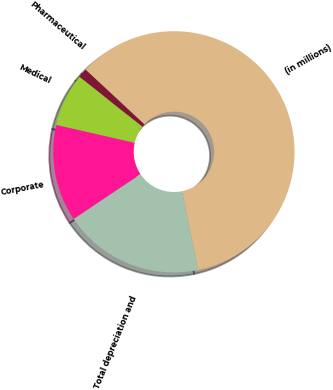Convert chart. <chart><loc_0><loc_0><loc_500><loc_500><pie_chart><fcel>(in millions)<fcel>Pharmaceutical<fcel>Medical<fcel>Corporate<fcel>Total depreciation and<nl><fcel>59.85%<fcel>1.25%<fcel>7.11%<fcel>12.97%<fcel>18.83%<nl></chart> 